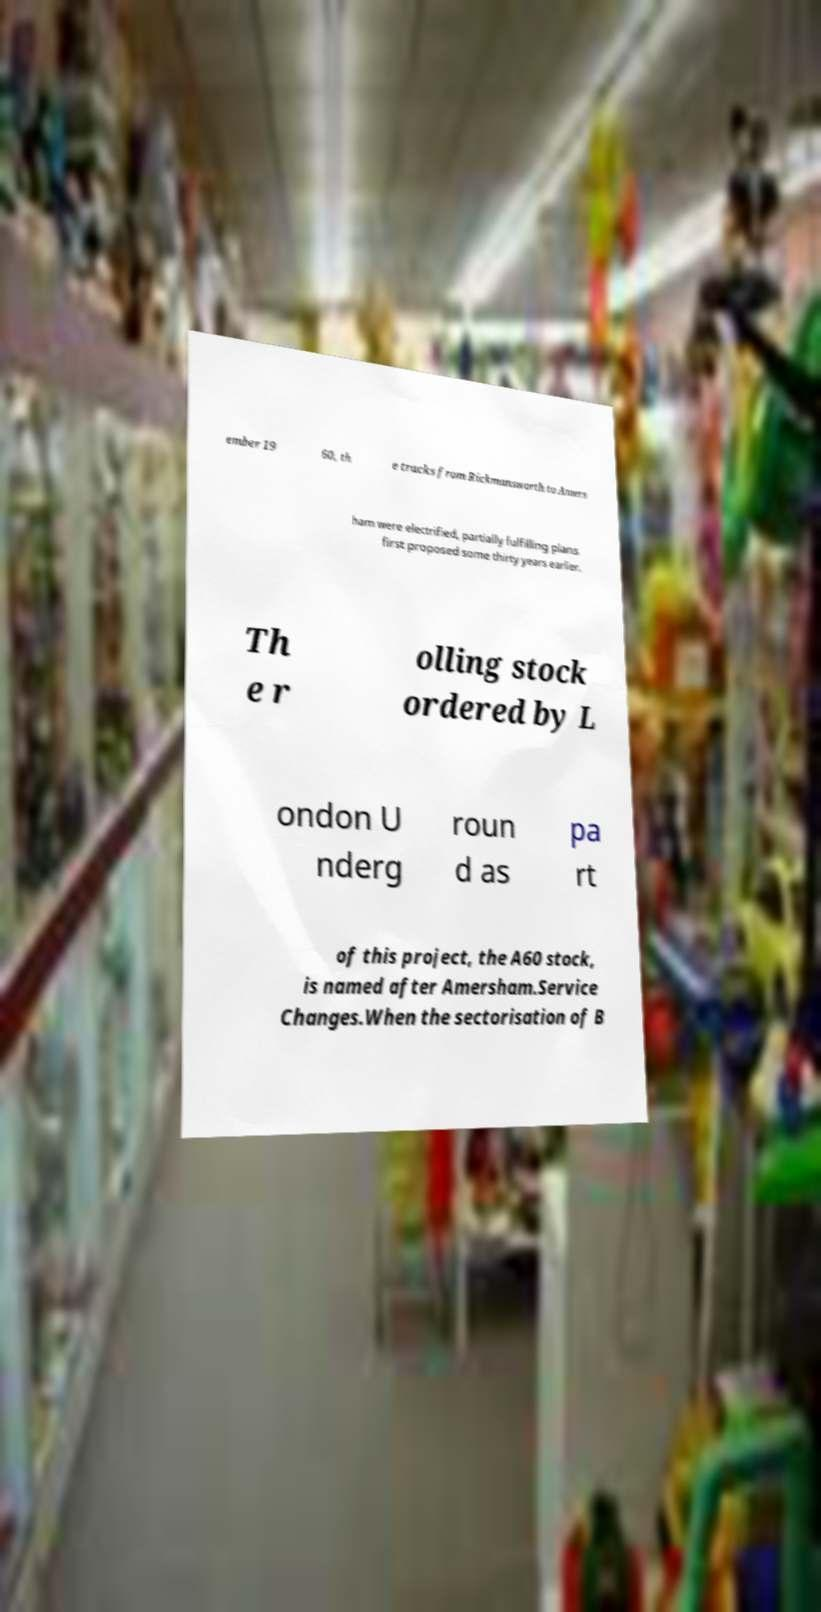What messages or text are displayed in this image? I need them in a readable, typed format. ember 19 60, th e tracks from Rickmansworth to Amers ham were electrified, partially fulfilling plans first proposed some thirty years earlier. Th e r olling stock ordered by L ondon U nderg roun d as pa rt of this project, the A60 stock, is named after Amersham.Service Changes.When the sectorisation of B 